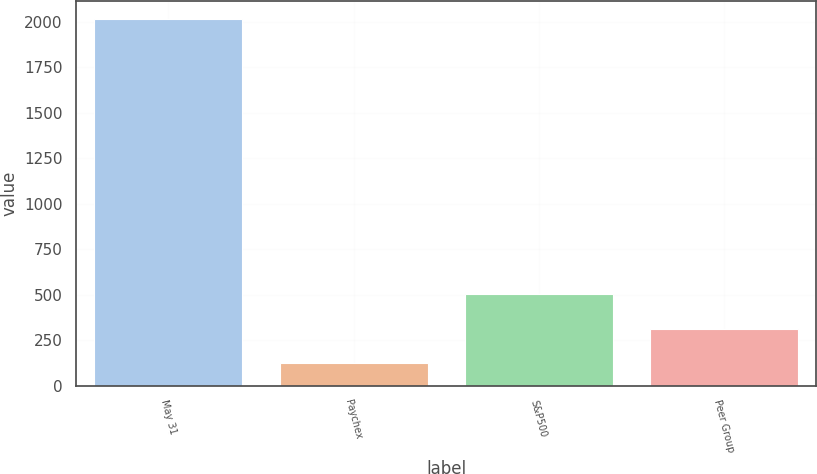<chart> <loc_0><loc_0><loc_500><loc_500><bar_chart><fcel>May 31<fcel>Paychex<fcel>S&P500<fcel>Peer Group<nl><fcel>2012<fcel>124.54<fcel>502.04<fcel>313.29<nl></chart> 